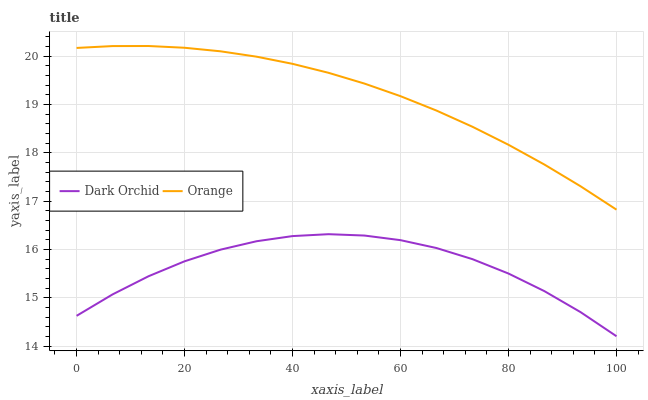Does Dark Orchid have the minimum area under the curve?
Answer yes or no. Yes. Does Orange have the maximum area under the curve?
Answer yes or no. Yes. Does Dark Orchid have the maximum area under the curve?
Answer yes or no. No. Is Orange the smoothest?
Answer yes or no. Yes. Is Dark Orchid the roughest?
Answer yes or no. Yes. Is Dark Orchid the smoothest?
Answer yes or no. No. Does Dark Orchid have the lowest value?
Answer yes or no. Yes. Does Orange have the highest value?
Answer yes or no. Yes. Does Dark Orchid have the highest value?
Answer yes or no. No. Is Dark Orchid less than Orange?
Answer yes or no. Yes. Is Orange greater than Dark Orchid?
Answer yes or no. Yes. Does Dark Orchid intersect Orange?
Answer yes or no. No. 